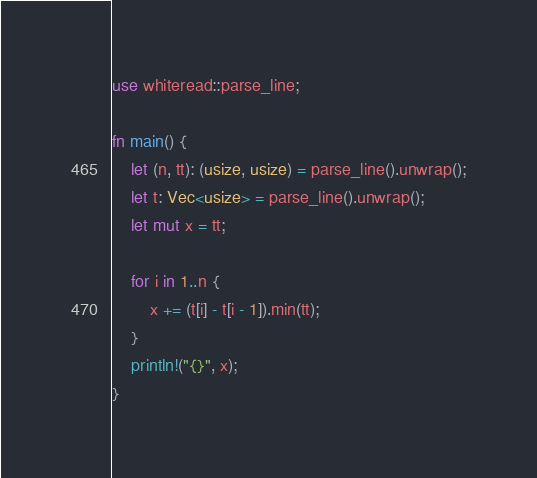Convert code to text. <code><loc_0><loc_0><loc_500><loc_500><_Rust_>use whiteread::parse_line;

fn main() {
    let (n, tt): (usize, usize) = parse_line().unwrap();
    let t: Vec<usize> = parse_line().unwrap();
    let mut x = tt;

    for i in 1..n {
        x += (t[i] - t[i - 1]).min(tt);
    }
    println!("{}", x);
}
</code> 